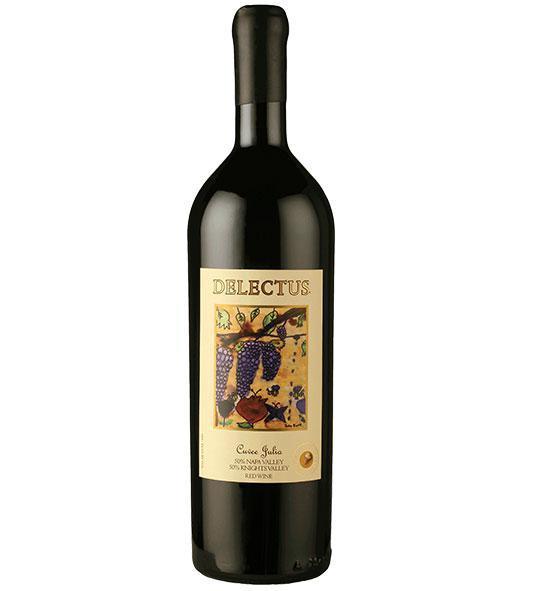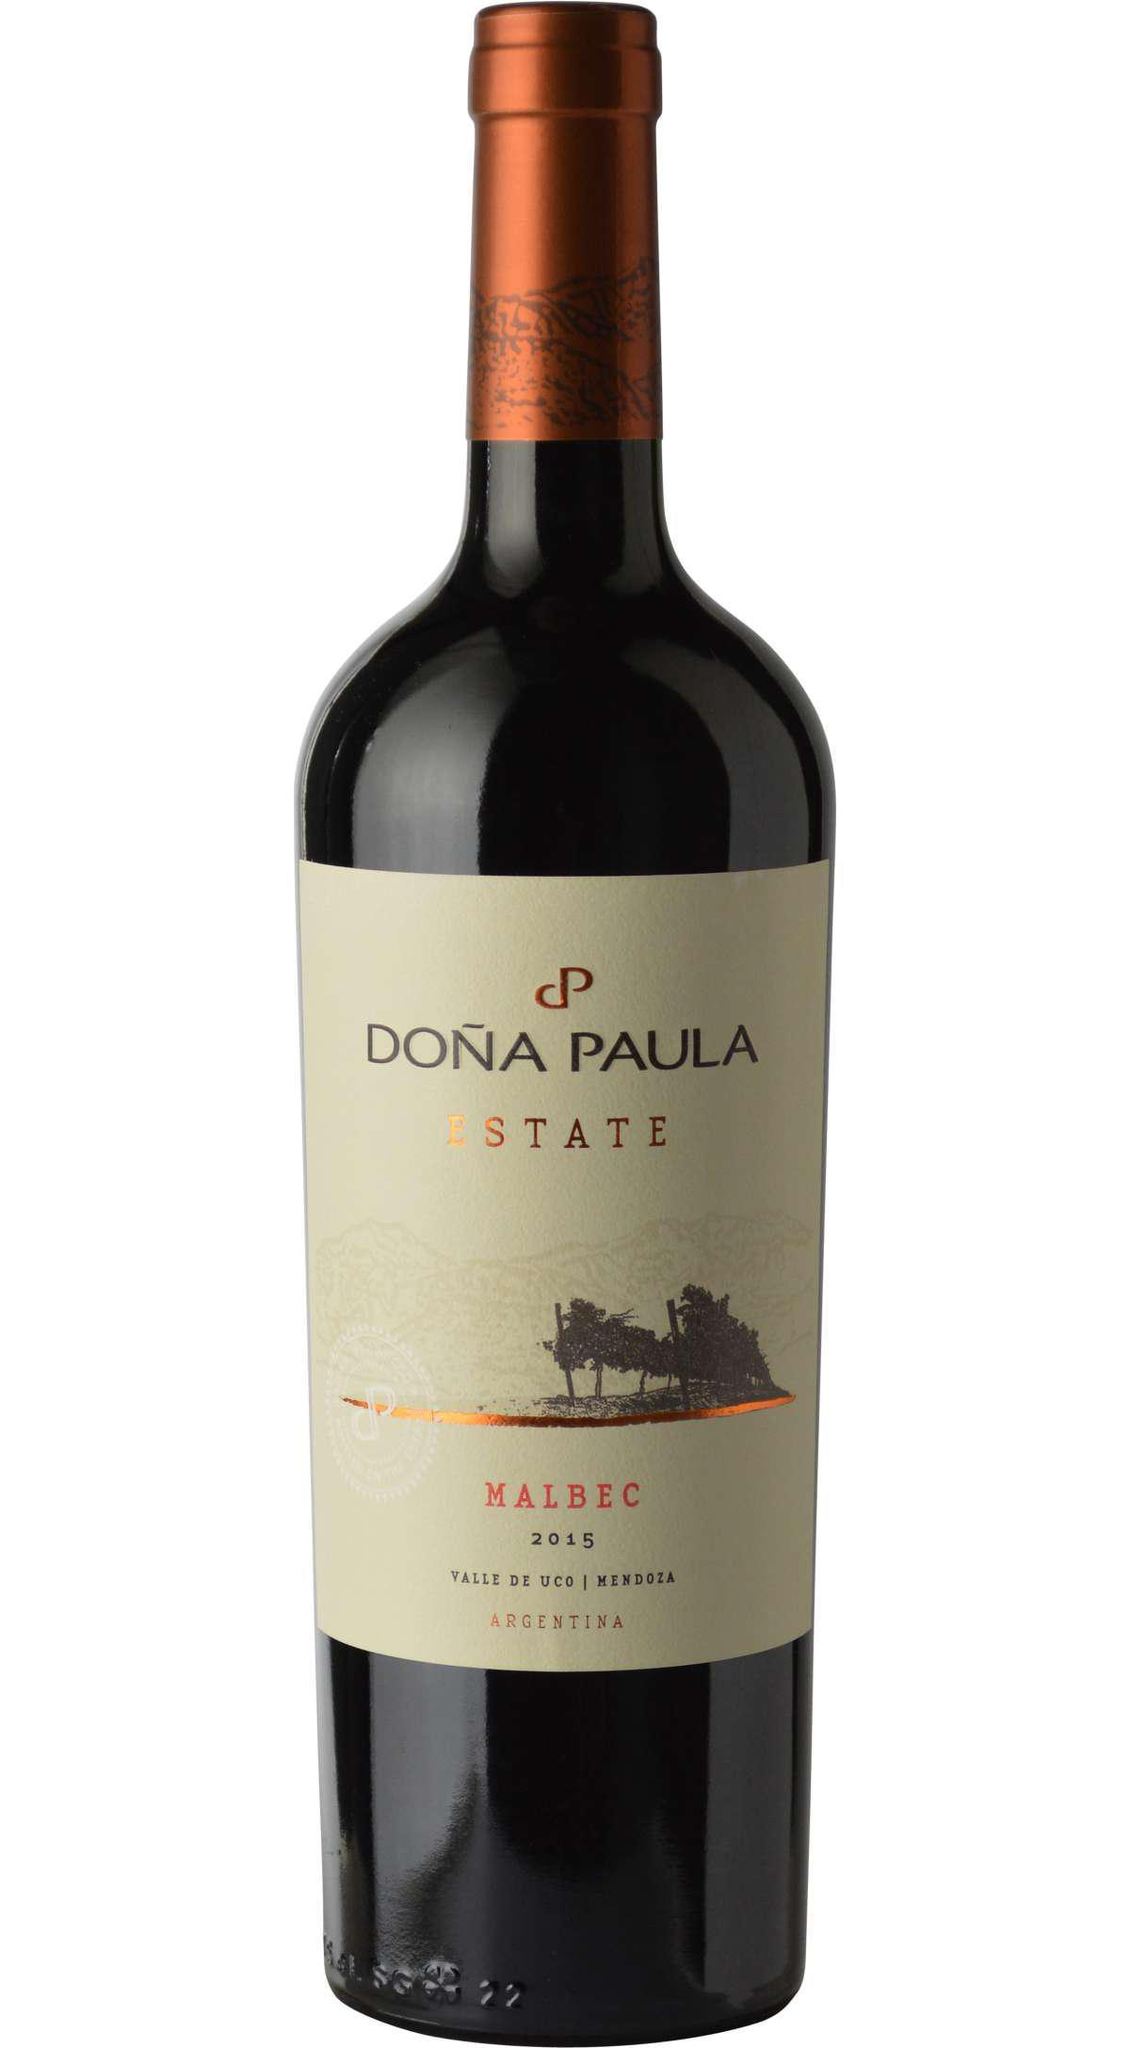The first image is the image on the left, the second image is the image on the right. Given the left and right images, does the statement "There is at least 1 wine bottle with a red cap." hold true? Answer yes or no. No. The first image is the image on the left, the second image is the image on the right. Considering the images on both sides, is "at least one bottle has a tan colored top" valid? Answer yes or no. No. 